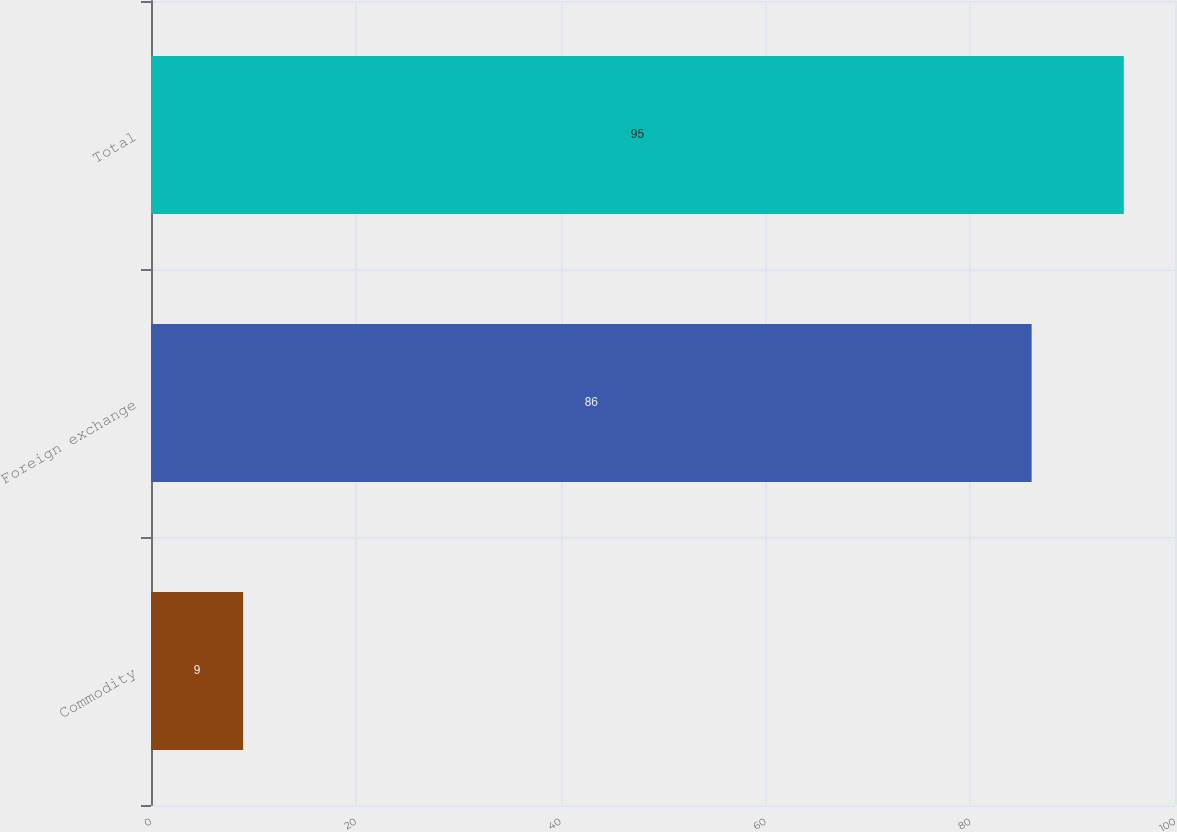<chart> <loc_0><loc_0><loc_500><loc_500><bar_chart><fcel>Commodity<fcel>Foreign exchange<fcel>Total<nl><fcel>9<fcel>86<fcel>95<nl></chart> 